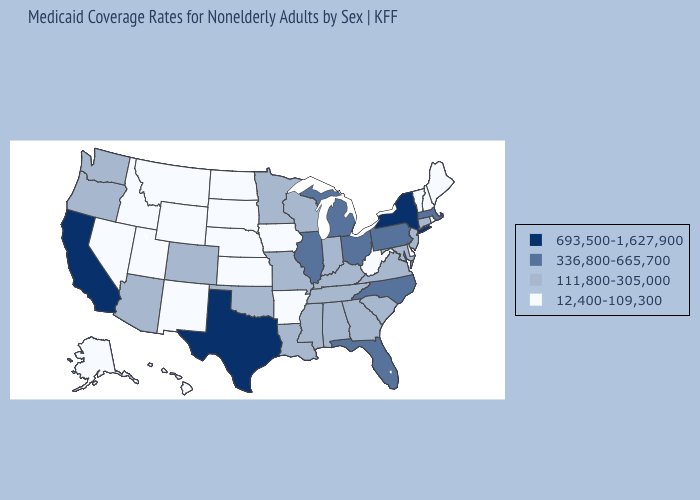What is the value of Mississippi?
Keep it brief. 111,800-305,000. Does the map have missing data?
Concise answer only. No. Does Wisconsin have a lower value than Virginia?
Concise answer only. No. Is the legend a continuous bar?
Short answer required. No. Does Hawaii have the lowest value in the USA?
Give a very brief answer. Yes. Does Nevada have the highest value in the West?
Keep it brief. No. Does New York have the highest value in the USA?
Concise answer only. Yes. Name the states that have a value in the range 12,400-109,300?
Write a very short answer. Alaska, Arkansas, Delaware, Hawaii, Idaho, Iowa, Kansas, Maine, Montana, Nebraska, Nevada, New Hampshire, New Mexico, North Dakota, Rhode Island, South Dakota, Utah, Vermont, West Virginia, Wyoming. Among the states that border Pennsylvania , which have the highest value?
Short answer required. New York. What is the value of Illinois?
Give a very brief answer. 336,800-665,700. Among the states that border Kentucky , does Illinois have the highest value?
Quick response, please. Yes. What is the lowest value in states that border Louisiana?
Write a very short answer. 12,400-109,300. What is the value of Minnesota?
Concise answer only. 111,800-305,000. Does Oregon have a higher value than Maryland?
Concise answer only. No. 